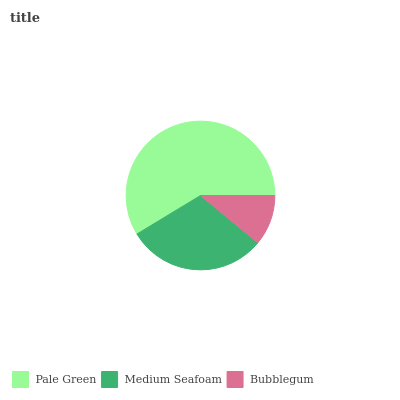Is Bubblegum the minimum?
Answer yes or no. Yes. Is Pale Green the maximum?
Answer yes or no. Yes. Is Medium Seafoam the minimum?
Answer yes or no. No. Is Medium Seafoam the maximum?
Answer yes or no. No. Is Pale Green greater than Medium Seafoam?
Answer yes or no. Yes. Is Medium Seafoam less than Pale Green?
Answer yes or no. Yes. Is Medium Seafoam greater than Pale Green?
Answer yes or no. No. Is Pale Green less than Medium Seafoam?
Answer yes or no. No. Is Medium Seafoam the high median?
Answer yes or no. Yes. Is Medium Seafoam the low median?
Answer yes or no. Yes. Is Bubblegum the high median?
Answer yes or no. No. Is Pale Green the low median?
Answer yes or no. No. 